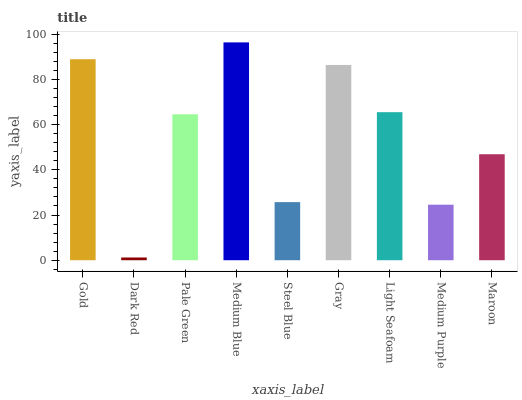Is Dark Red the minimum?
Answer yes or no. Yes. Is Medium Blue the maximum?
Answer yes or no. Yes. Is Pale Green the minimum?
Answer yes or no. No. Is Pale Green the maximum?
Answer yes or no. No. Is Pale Green greater than Dark Red?
Answer yes or no. Yes. Is Dark Red less than Pale Green?
Answer yes or no. Yes. Is Dark Red greater than Pale Green?
Answer yes or no. No. Is Pale Green less than Dark Red?
Answer yes or no. No. Is Pale Green the high median?
Answer yes or no. Yes. Is Pale Green the low median?
Answer yes or no. Yes. Is Medium Purple the high median?
Answer yes or no. No. Is Dark Red the low median?
Answer yes or no. No. 